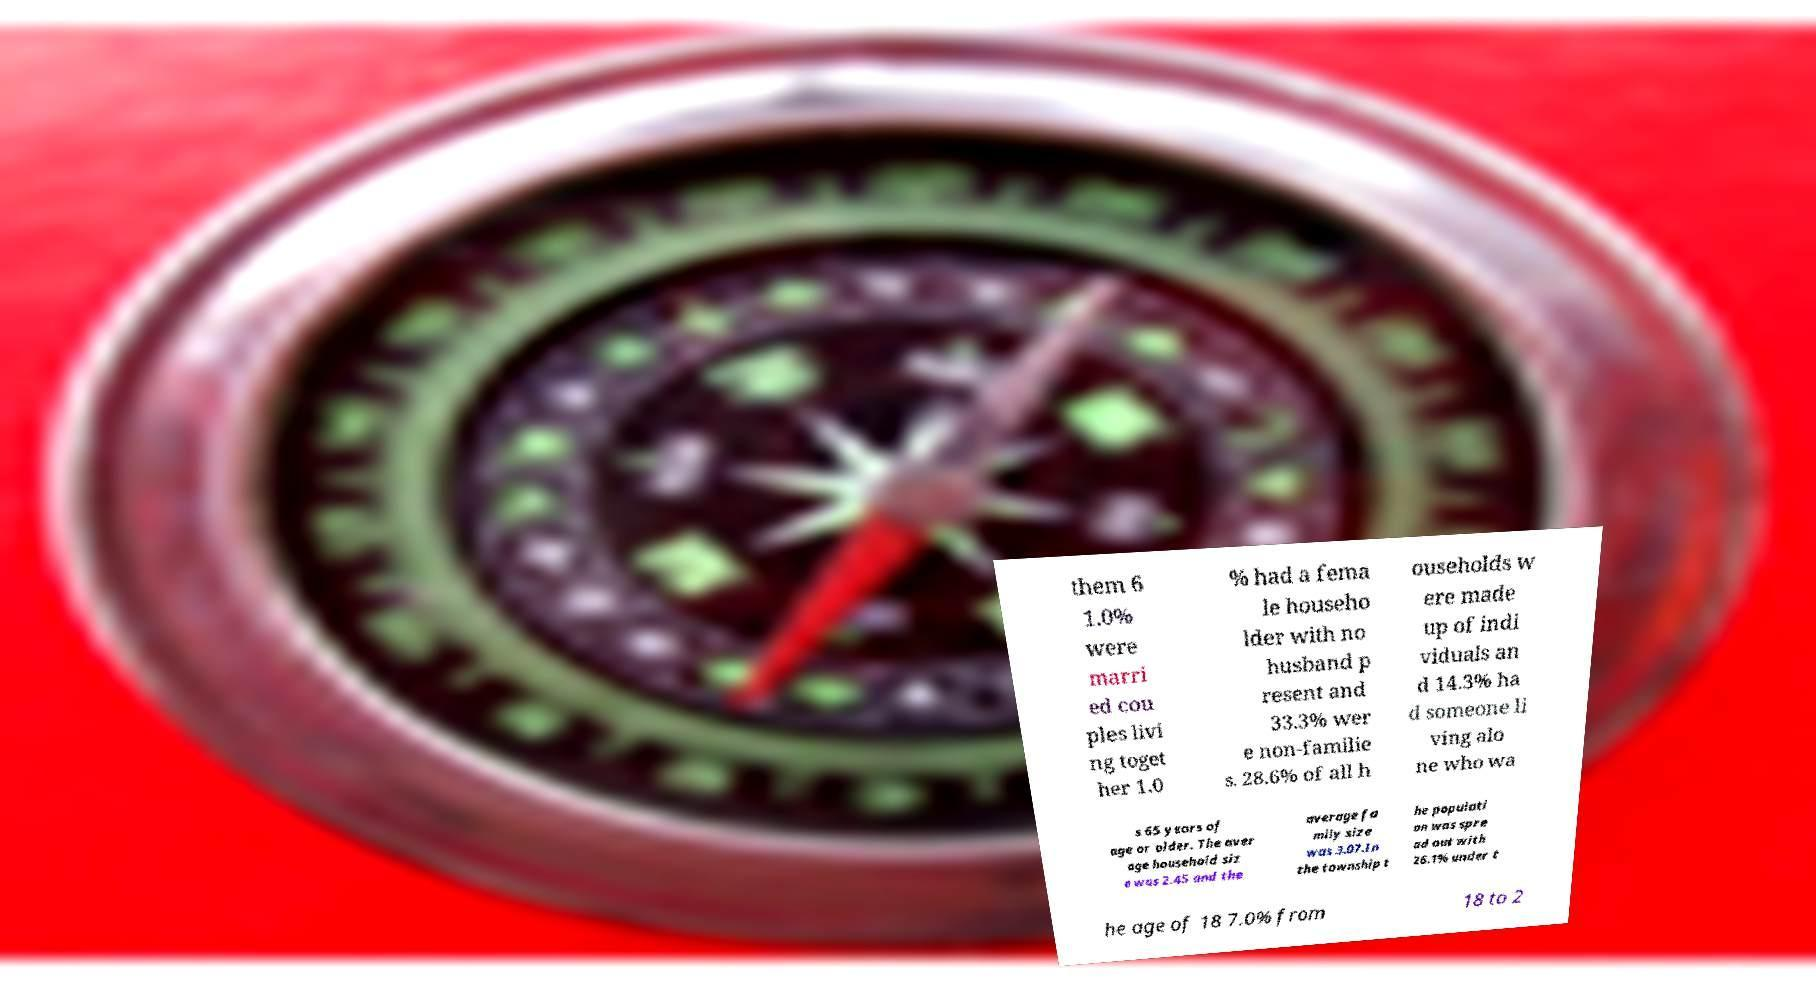Can you accurately transcribe the text from the provided image for me? them 6 1.0% were marri ed cou ples livi ng toget her 1.0 % had a fema le househo lder with no husband p resent and 33.3% wer e non-familie s. 28.6% of all h ouseholds w ere made up of indi viduals an d 14.3% ha d someone li ving alo ne who wa s 65 years of age or older. The aver age household siz e was 2.45 and the average fa mily size was 3.07.In the township t he populati on was spre ad out with 26.1% under t he age of 18 7.0% from 18 to 2 